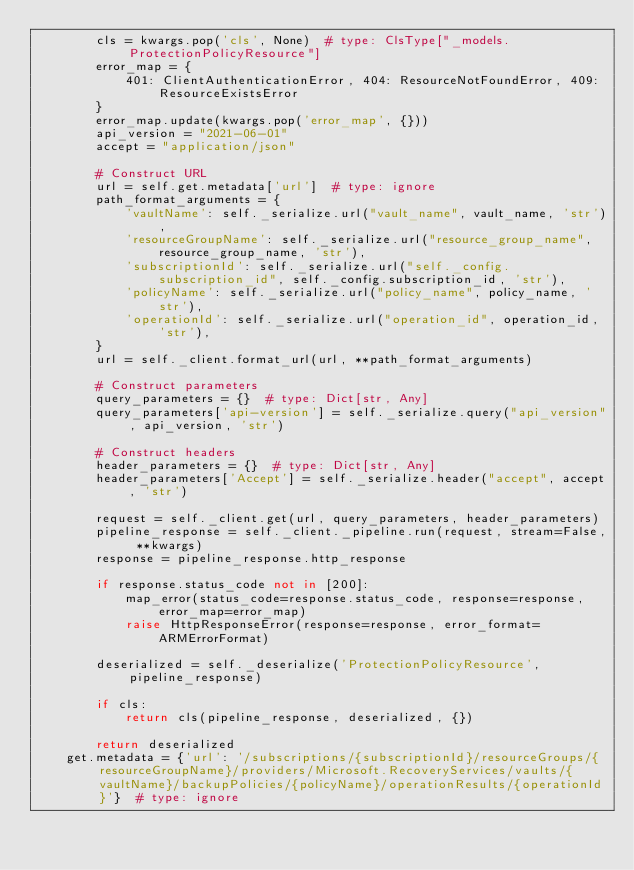<code> <loc_0><loc_0><loc_500><loc_500><_Python_>        cls = kwargs.pop('cls', None)  # type: ClsType["_models.ProtectionPolicyResource"]
        error_map = {
            401: ClientAuthenticationError, 404: ResourceNotFoundError, 409: ResourceExistsError
        }
        error_map.update(kwargs.pop('error_map', {}))
        api_version = "2021-06-01"
        accept = "application/json"

        # Construct URL
        url = self.get.metadata['url']  # type: ignore
        path_format_arguments = {
            'vaultName': self._serialize.url("vault_name", vault_name, 'str'),
            'resourceGroupName': self._serialize.url("resource_group_name", resource_group_name, 'str'),
            'subscriptionId': self._serialize.url("self._config.subscription_id", self._config.subscription_id, 'str'),
            'policyName': self._serialize.url("policy_name", policy_name, 'str'),
            'operationId': self._serialize.url("operation_id", operation_id, 'str'),
        }
        url = self._client.format_url(url, **path_format_arguments)

        # Construct parameters
        query_parameters = {}  # type: Dict[str, Any]
        query_parameters['api-version'] = self._serialize.query("api_version", api_version, 'str')

        # Construct headers
        header_parameters = {}  # type: Dict[str, Any]
        header_parameters['Accept'] = self._serialize.header("accept", accept, 'str')

        request = self._client.get(url, query_parameters, header_parameters)
        pipeline_response = self._client._pipeline.run(request, stream=False, **kwargs)
        response = pipeline_response.http_response

        if response.status_code not in [200]:
            map_error(status_code=response.status_code, response=response, error_map=error_map)
            raise HttpResponseError(response=response, error_format=ARMErrorFormat)

        deserialized = self._deserialize('ProtectionPolicyResource', pipeline_response)

        if cls:
            return cls(pipeline_response, deserialized, {})

        return deserialized
    get.metadata = {'url': '/subscriptions/{subscriptionId}/resourceGroups/{resourceGroupName}/providers/Microsoft.RecoveryServices/vaults/{vaultName}/backupPolicies/{policyName}/operationResults/{operationId}'}  # type: ignore
</code> 